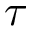Convert formula to latex. <formula><loc_0><loc_0><loc_500><loc_500>\tau</formula> 